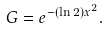Convert formula to latex. <formula><loc_0><loc_0><loc_500><loc_500>G = e ^ { - ( \ln 2 ) x ^ { 2 } } .</formula> 